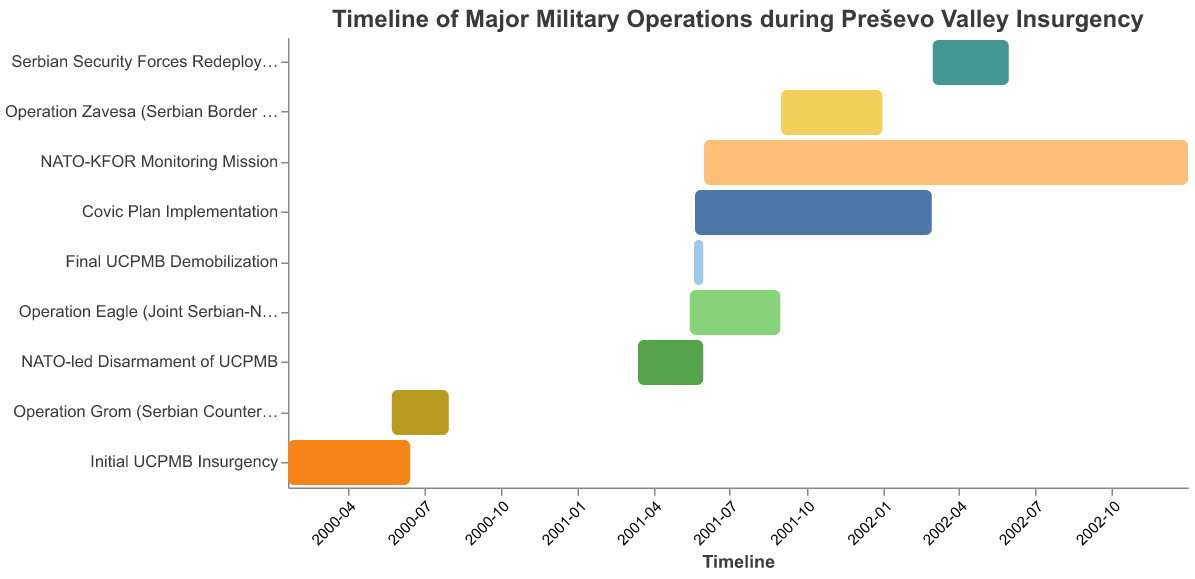What is the duration of the Initial UCPMB Insurgency? The Initial UCPMB Insurgency started on 2000-01-21 and ended on 2000-06-15. The duration is calculated by finding the difference between these two dates.
Answer: About 5 months Which military operation had the longest duration? By comparing the start and end dates of each operation, NATO-KFOR Monitoring Mission lasted the longest from 2001-06-01 to 2002-12-31.
Answer: NATO-KFOR Monitoring Mission Which two military operations overlapped in May 2001? Operation Eagle started on 2001-05-15 and Covic Plan Implementation started on 2001-05-21, both overlapping in May 2001.
Answer: Operation Eagle and Covic Plan Implementation When did the NATO-led Disarmament of UCPMB begin and end? NATO-led Disarmament of UCPMB started on 2001-03-14 and ended on 2001-05-31, as shown on the timeline.
Answer: 2001-03-14 to 2001-05-31 Which operation immediately succeeded Operation Grom? Referring to the timeline, the next operation after Operation Grom ended on 2000-07-31 was NATO-led Disarmament of UCPMB, starting on 2001-03-14.
Answer: NATO-led Disarmament of UCPMB What is the overlap period between Operation Eagle and Final UCPMB Demobilization? Operation Eagle started on 2001-05-15 and Final UCPMB Demobilization started on 2001-05-20 and ended on 2001-05-31, so the overlap period is from 2001-05-20 to 2001-05-31.
Answer: 2001-05-20 to 2001-05-31 How long did the Covic Plan Implementation last? The Covic Plan Implementation started on 2001-05-21 and ended on 2002-02-28. The duration is about 9 months and 1 week.
Answer: About 9 months and 1 week Which operational phase ended in December 2001? Based on the end dates, Operation Zavesa ended on 2001-12-31.
Answer: Operation Zavesa 